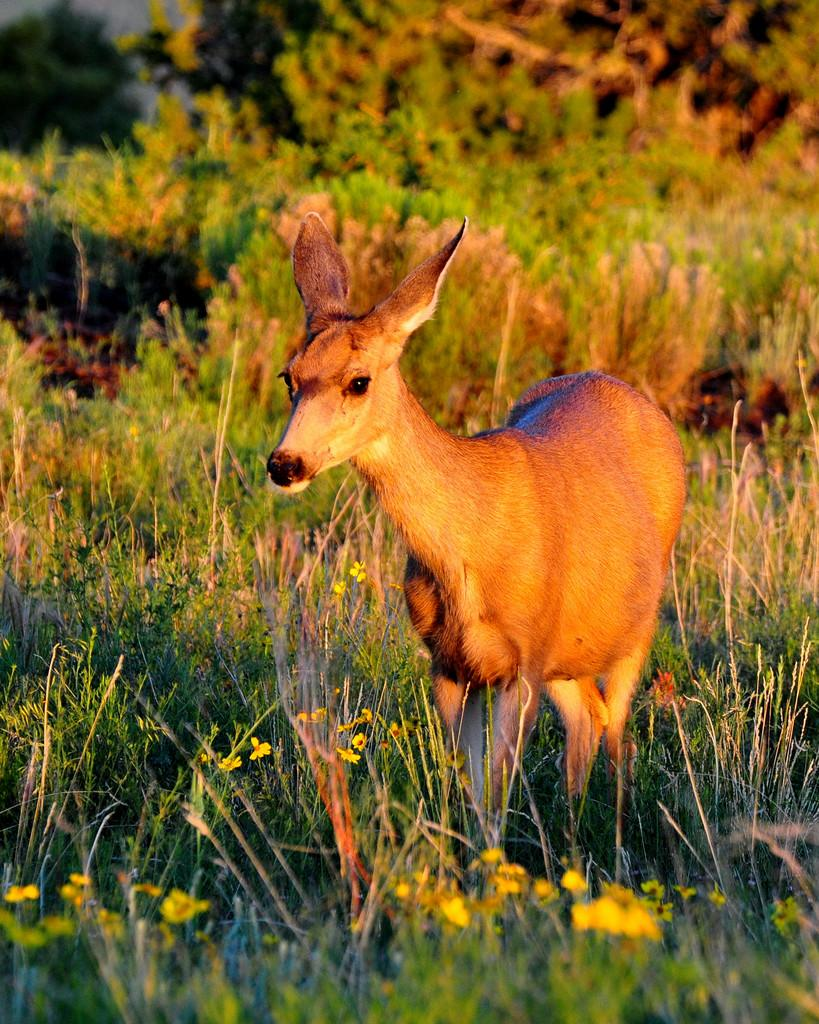What type of animal can be seen in the image? There is an animal in the image, and it is brown in color. Where is the animal located in the image? The animal is standing on the grass. What can be found on the grass in the image? There are yellow flowers on the grass. What is visible in the background of the image? There are many trees in the background of the image. What type of bomb can be seen in the image? There is no bomb present in the image; it features an animal standing on the grass with yellow flowers and trees in the background. 